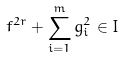Convert formula to latex. <formula><loc_0><loc_0><loc_500><loc_500>f ^ { 2 r } + \sum _ { i = 1 } ^ { m } g _ { i } ^ { 2 } \in I</formula> 